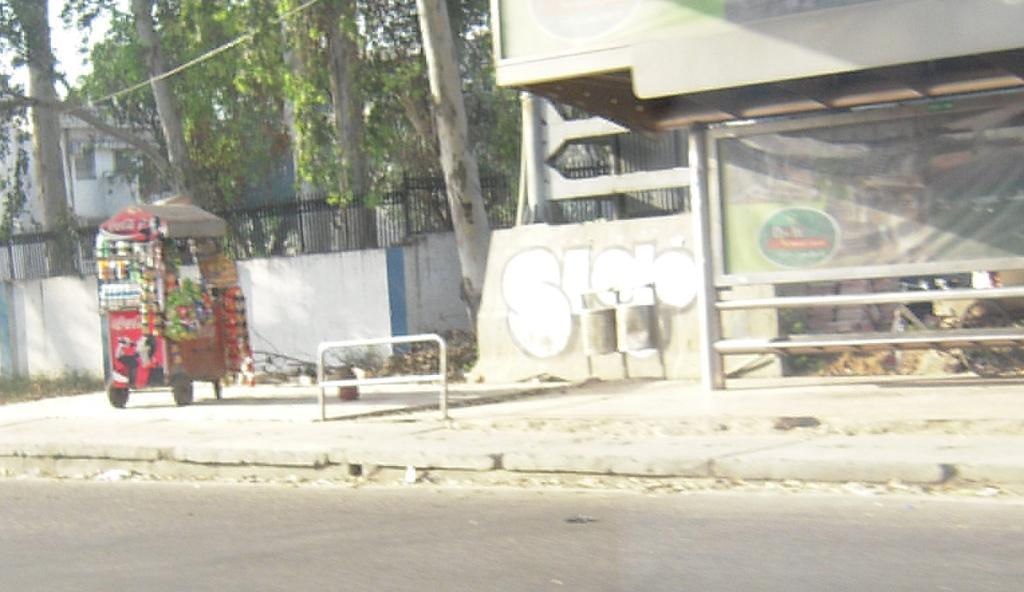What is located at the stall in the image? The facts do not specify what objects are at the stall, so we cannot answer this question definitively. What type of barrier is present near the wall in the image? There is an iron fence near the wall in the image. What type of structure can be seen in the image besides the stall and wall? There is a shed in the image. What type of natural elements are present in the image? Trees are present in the image. What can be seen in the distance in the image? There is a building in the background of the image, and the sky is visible as well. How many friends are sitting on the quarter in the image? There is no quarter or friends present in the image. 